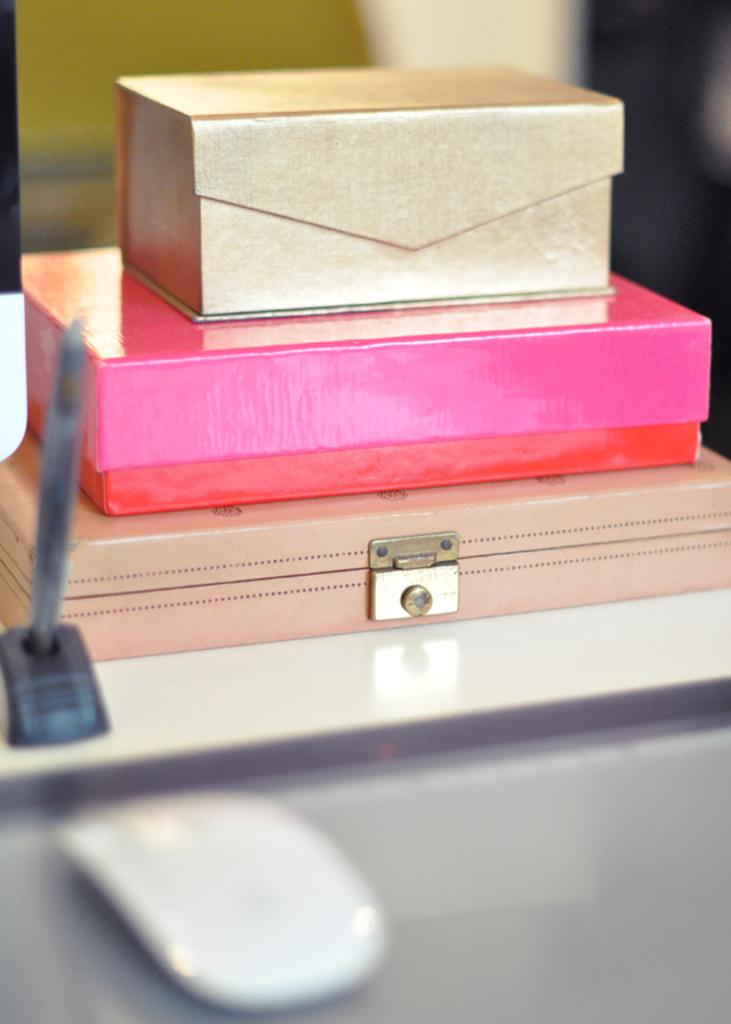How many boxes are visible in the image? There are three boxes in the image. What is located in the foreground of the image? There is a mouse in the foreground of the image. What is on the table in the image? There is an object on a table in the image. Can you describe the background of the image? The background of the image is blurry. What type of soda is the mouse drinking in the image? There is no soda present in the image; it features a mouse in the foreground and three boxes. How does the mouse kick the object on the table in the image? There is no indication of the mouse kicking anything in the image; it is simply located in the foreground. 